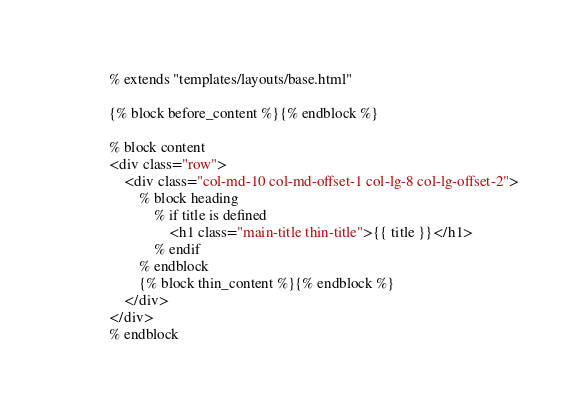<code> <loc_0><loc_0><loc_500><loc_500><_HTML_>% extends "templates/layouts/base.html"

{% block before_content %}{% endblock %}

% block content
<div class="row">
    <div class="col-md-10 col-md-offset-1 col-lg-8 col-lg-offset-2">
        % block heading
            % if title is defined
                <h1 class="main-title thin-title">{{ title }}</h1>
            % endif
        % endblock
        {% block thin_content %}{% endblock %}
    </div>
</div>
% endblock
</code> 